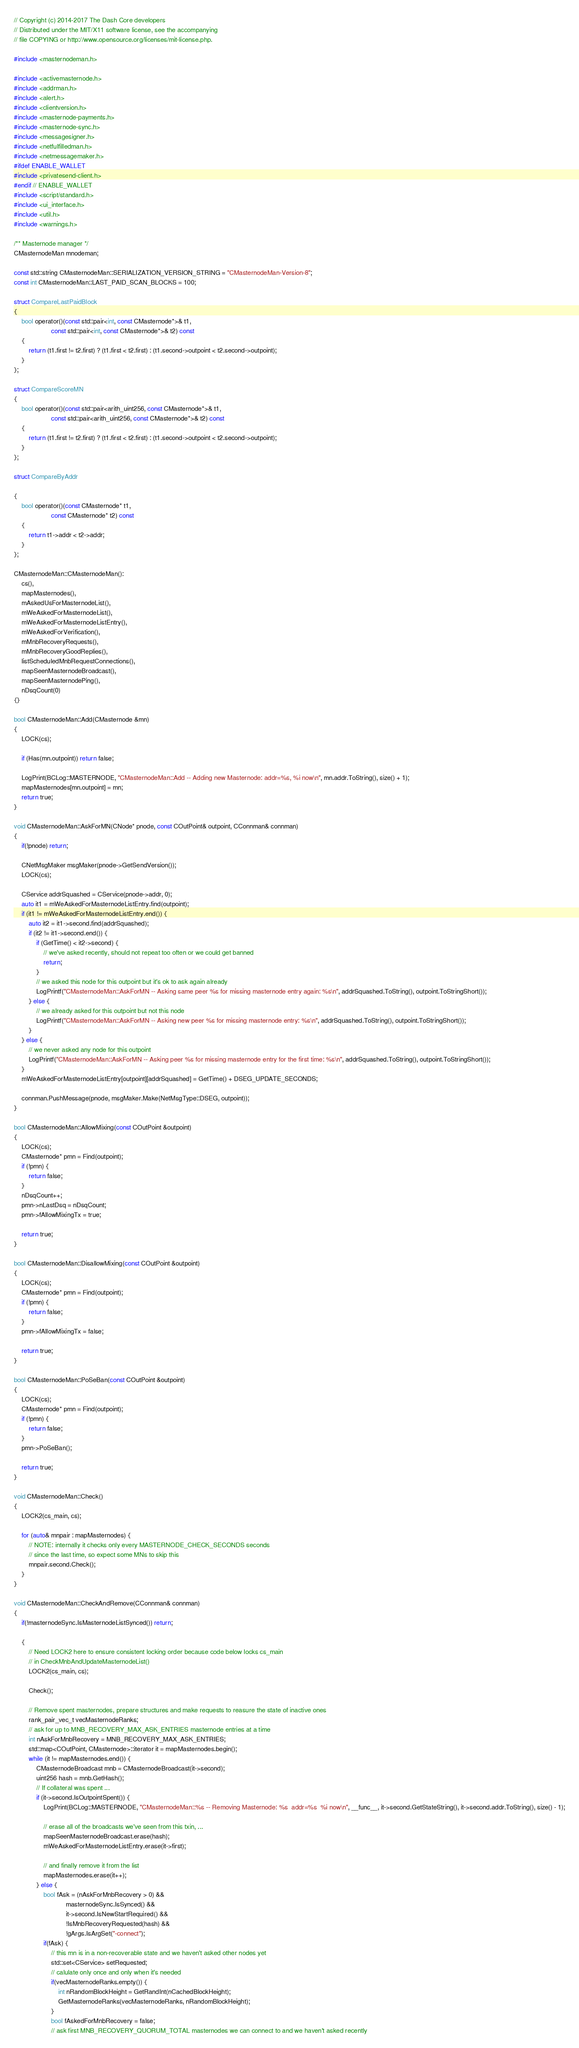Convert code to text. <code><loc_0><loc_0><loc_500><loc_500><_C++_>// Copyright (c) 2014-2017 The Dash Core developers
// Distributed under the MIT/X11 software license, see the accompanying
// file COPYING or http://www.opensource.org/licenses/mit-license.php.

#include <masternodeman.h>

#include <activemasternode.h>
#include <addrman.h>
#include <alert.h>
#include <clientversion.h>
#include <masternode-payments.h>
#include <masternode-sync.h>
#include <messagesigner.h>
#include <netfulfilledman.h>
#include <netmessagemaker.h>
#ifdef ENABLE_WALLET
#include <privatesend-client.h>
#endif // ENABLE_WALLET
#include <script/standard.h>
#include <ui_interface.h>
#include <util.h>
#include <warnings.h>

/** Masternode manager */
CMasternodeMan mnodeman;

const std::string CMasternodeMan::SERIALIZATION_VERSION_STRING = "CMasternodeMan-Version-8";
const int CMasternodeMan::LAST_PAID_SCAN_BLOCKS = 100;

struct CompareLastPaidBlock
{
    bool operator()(const std::pair<int, const CMasternode*>& t1,
                    const std::pair<int, const CMasternode*>& t2) const
    {
        return (t1.first != t2.first) ? (t1.first < t2.first) : (t1.second->outpoint < t2.second->outpoint);
    }
};

struct CompareScoreMN
{
    bool operator()(const std::pair<arith_uint256, const CMasternode*>& t1,
                    const std::pair<arith_uint256, const CMasternode*>& t2) const
    {
        return (t1.first != t2.first) ? (t1.first < t2.first) : (t1.second->outpoint < t2.second->outpoint);
    }
};

struct CompareByAddr

{
    bool operator()(const CMasternode* t1,
                    const CMasternode* t2) const
    {
        return t1->addr < t2->addr;
    }
};

CMasternodeMan::CMasternodeMan():
    cs(),
    mapMasternodes(),
    mAskedUsForMasternodeList(),
    mWeAskedForMasternodeList(),
    mWeAskedForMasternodeListEntry(),
    mWeAskedForVerification(),
    mMnbRecoveryRequests(),
    mMnbRecoveryGoodReplies(),
    listScheduledMnbRequestConnections(),
    mapSeenMasternodeBroadcast(),
    mapSeenMasternodePing(),
    nDsqCount(0)
{}

bool CMasternodeMan::Add(CMasternode &mn)
{
    LOCK(cs);

    if (Has(mn.outpoint)) return false;

    LogPrint(BCLog::MASTERNODE, "CMasternodeMan::Add -- Adding new Masternode: addr=%s, %i now\n", mn.addr.ToString(), size() + 1);
    mapMasternodes[mn.outpoint] = mn;
    return true;
}

void CMasternodeMan::AskForMN(CNode* pnode, const COutPoint& outpoint, CConnman& connman)
{
    if(!pnode) return;

    CNetMsgMaker msgMaker(pnode->GetSendVersion());
    LOCK(cs);

    CService addrSquashed = CService(pnode->addr, 0);
    auto it1 = mWeAskedForMasternodeListEntry.find(outpoint);
    if (it1 != mWeAskedForMasternodeListEntry.end()) {
        auto it2 = it1->second.find(addrSquashed);
        if (it2 != it1->second.end()) {
            if (GetTime() < it2->second) {
                // we've asked recently, should not repeat too often or we could get banned
                return;
            }
            // we asked this node for this outpoint but it's ok to ask again already
            LogPrintf("CMasternodeMan::AskForMN -- Asking same peer %s for missing masternode entry again: %s\n", addrSquashed.ToString(), outpoint.ToStringShort());
        } else {
            // we already asked for this outpoint but not this node
            LogPrintf("CMasternodeMan::AskForMN -- Asking new peer %s for missing masternode entry: %s\n", addrSquashed.ToString(), outpoint.ToStringShort());
        }
    } else {
        // we never asked any node for this outpoint
        LogPrintf("CMasternodeMan::AskForMN -- Asking peer %s for missing masternode entry for the first time: %s\n", addrSquashed.ToString(), outpoint.ToStringShort());
    }
    mWeAskedForMasternodeListEntry[outpoint][addrSquashed] = GetTime() + DSEG_UPDATE_SECONDS;

    connman.PushMessage(pnode, msgMaker.Make(NetMsgType::DSEG, outpoint));
}

bool CMasternodeMan::AllowMixing(const COutPoint &outpoint)
{
    LOCK(cs);
    CMasternode* pmn = Find(outpoint);
    if (!pmn) {
        return false;
    }
    nDsqCount++;
    pmn->nLastDsq = nDsqCount;
    pmn->fAllowMixingTx = true;

    return true;
}

bool CMasternodeMan::DisallowMixing(const COutPoint &outpoint)
{
    LOCK(cs);
    CMasternode* pmn = Find(outpoint);
    if (!pmn) {
        return false;
    }
    pmn->fAllowMixingTx = false;

    return true;
}

bool CMasternodeMan::PoSeBan(const COutPoint &outpoint)
{
    LOCK(cs);
    CMasternode* pmn = Find(outpoint);
    if (!pmn) {
        return false;
    }
    pmn->PoSeBan();

    return true;
}

void CMasternodeMan::Check()
{
    LOCK2(cs_main, cs);

    for (auto& mnpair : mapMasternodes) {
        // NOTE: internally it checks only every MASTERNODE_CHECK_SECONDS seconds
        // since the last time, so expect some MNs to skip this
        mnpair.second.Check();
    }
}

void CMasternodeMan::CheckAndRemove(CConnman& connman)
{
    if(!masternodeSync.IsMasternodeListSynced()) return;

    {
        // Need LOCK2 here to ensure consistent locking order because code below locks cs_main
        // in CheckMnbAndUpdateMasternodeList()
        LOCK2(cs_main, cs);

        Check();

        // Remove spent masternodes, prepare structures and make requests to reasure the state of inactive ones
        rank_pair_vec_t vecMasternodeRanks;
        // ask for up to MNB_RECOVERY_MAX_ASK_ENTRIES masternode entries at a time
        int nAskForMnbRecovery = MNB_RECOVERY_MAX_ASK_ENTRIES;
        std::map<COutPoint, CMasternode>::iterator it = mapMasternodes.begin();
        while (it != mapMasternodes.end()) {
            CMasternodeBroadcast mnb = CMasternodeBroadcast(it->second);
            uint256 hash = mnb.GetHash();
            // If collateral was spent ...
            if (it->second.IsOutpointSpent()) {
                LogPrint(BCLog::MASTERNODE, "CMasternodeMan::%s -- Removing Masternode: %s  addr=%s  %i now\n", __func__, it->second.GetStateString(), it->second.addr.ToString(), size() - 1);

                // erase all of the broadcasts we've seen from this txin, ...
                mapSeenMasternodeBroadcast.erase(hash);
                mWeAskedForMasternodeListEntry.erase(it->first);

                // and finally remove it from the list
                mapMasternodes.erase(it++);
            } else {
                bool fAsk = (nAskForMnbRecovery > 0) &&
                            masternodeSync.IsSynced() &&
                            it->second.IsNewStartRequired() &&
                            !IsMnbRecoveryRequested(hash) &&
                            !gArgs.IsArgSet("-connect");
                if(fAsk) {
                    // this mn is in a non-recoverable state and we haven't asked other nodes yet
                    std::set<CService> setRequested;
                    // calulate only once and only when it's needed
                    if(vecMasternodeRanks.empty()) {
                        int nRandomBlockHeight = GetRandInt(nCachedBlockHeight);
                        GetMasternodeRanks(vecMasternodeRanks, nRandomBlockHeight);
                    }
                    bool fAskedForMnbRecovery = false;
                    // ask first MNB_RECOVERY_QUORUM_TOTAL masternodes we can connect to and we haven't asked recently</code> 